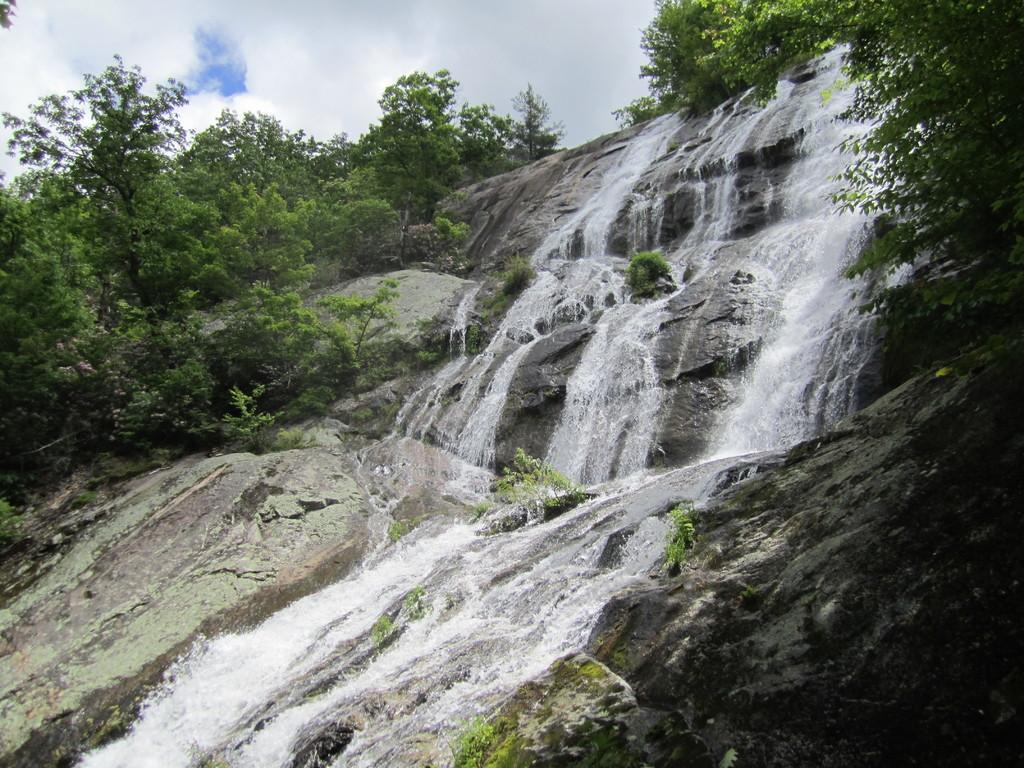Could you give a brief overview of what you see in this image? In this image I can see waterfall, number of trees, clouds and the sky. 